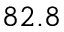Convert formula to latex. <formula><loc_0><loc_0><loc_500><loc_500>8 2 . 8</formula> 